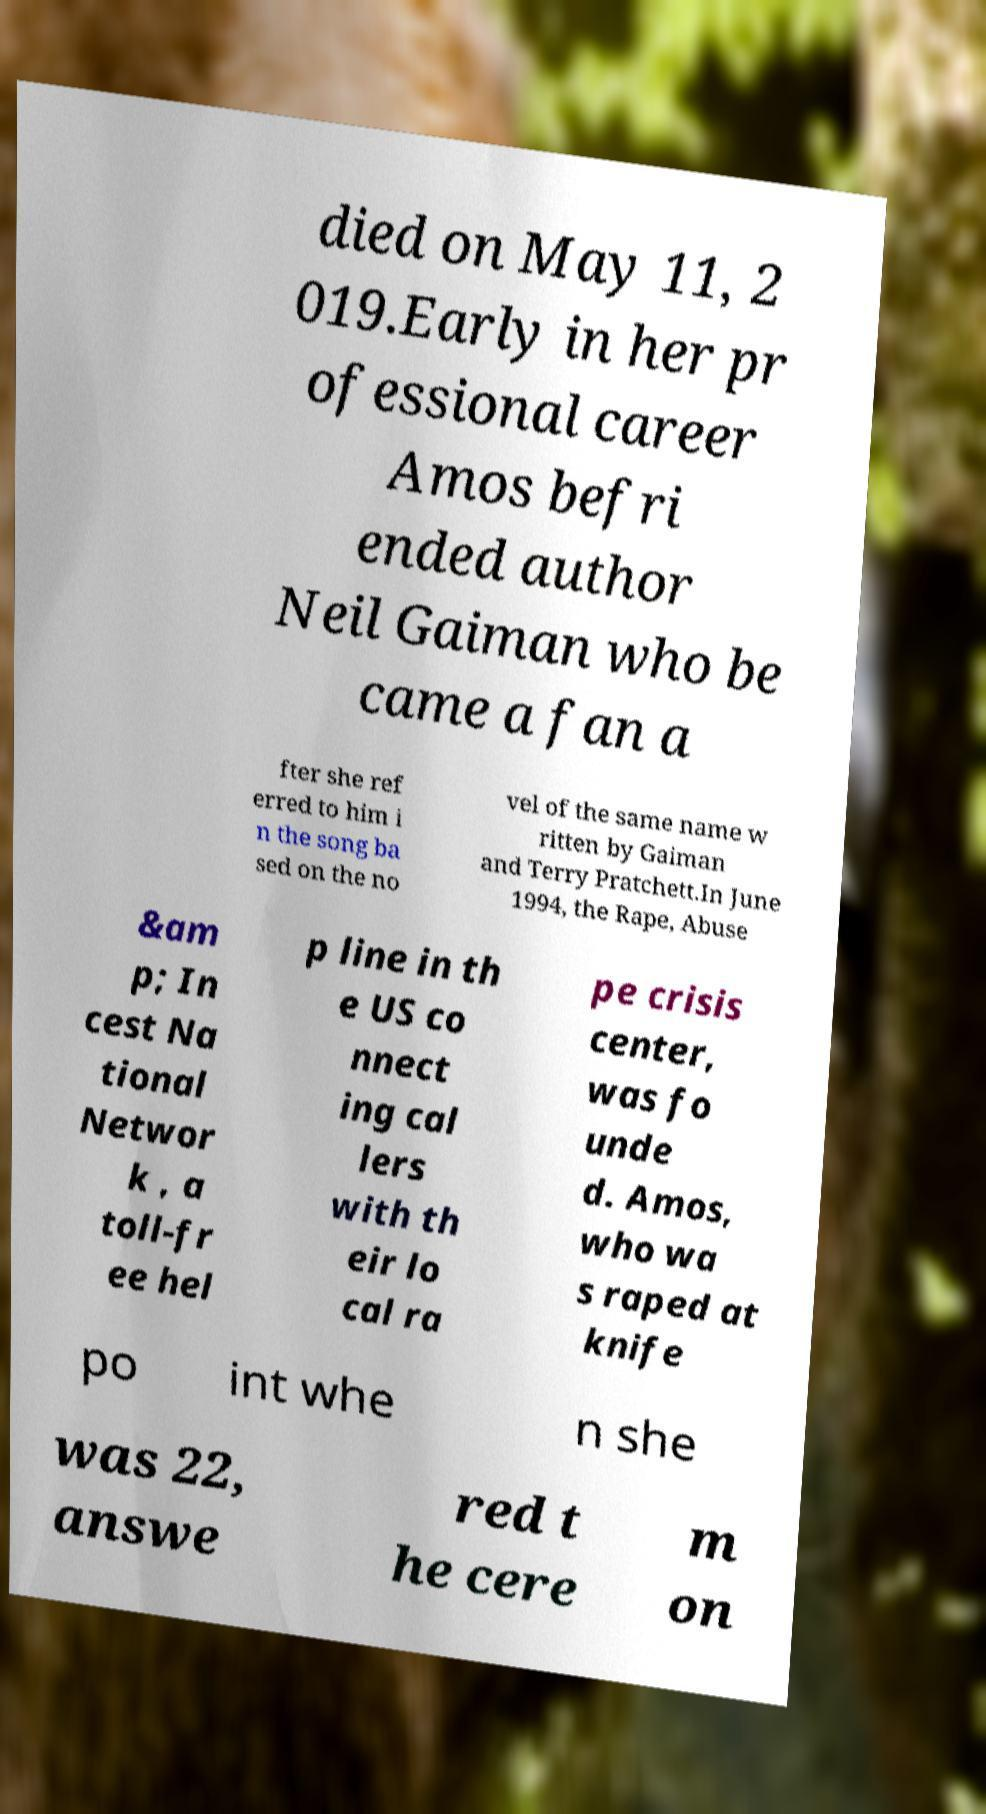Please identify and transcribe the text found in this image. died on May 11, 2 019.Early in her pr ofessional career Amos befri ended author Neil Gaiman who be came a fan a fter she ref erred to him i n the song ba sed on the no vel of the same name w ritten by Gaiman and Terry Pratchett.In June 1994, the Rape, Abuse &am p; In cest Na tional Networ k , a toll-fr ee hel p line in th e US co nnect ing cal lers with th eir lo cal ra pe crisis center, was fo unde d. Amos, who wa s raped at knife po int whe n she was 22, answe red t he cere m on 